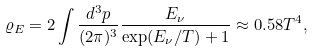<formula> <loc_0><loc_0><loc_500><loc_500>\varrho _ { E } = 2 \int \frac { d ^ { 3 } p } { ( 2 \pi ) ^ { 3 } } \frac { E _ { \nu } } { \exp ( E _ { \nu } / T ) + 1 } \approx 0 . 5 8 T ^ { 4 } ,</formula> 